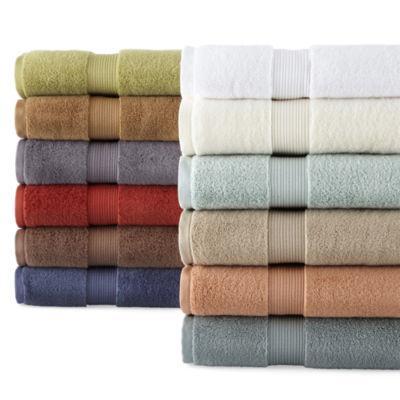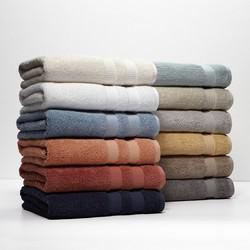The first image is the image on the left, the second image is the image on the right. For the images shown, is this caption "Each image shows exactly two piles of multiple towels in different solid colors." true? Answer yes or no. Yes. 